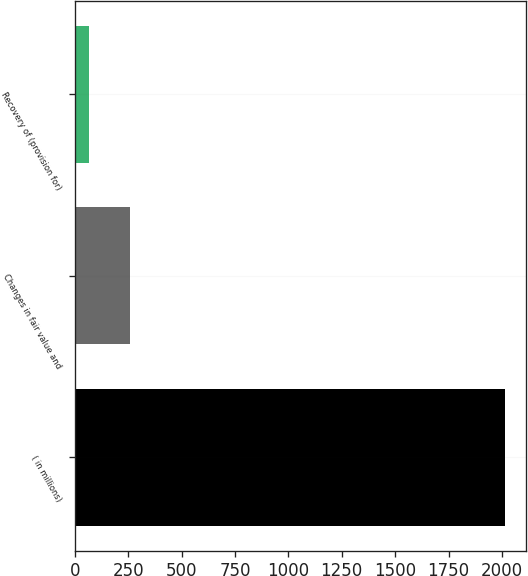Convert chart. <chart><loc_0><loc_0><loc_500><loc_500><bar_chart><fcel>( in millions)<fcel>Changes in fair value and<fcel>Recovery of (provision for)<nl><fcel>2014<fcel>259.9<fcel>65<nl></chart> 